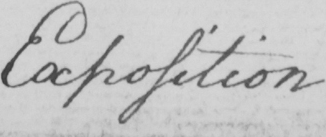Can you tell me what this handwritten text says? Exposition 